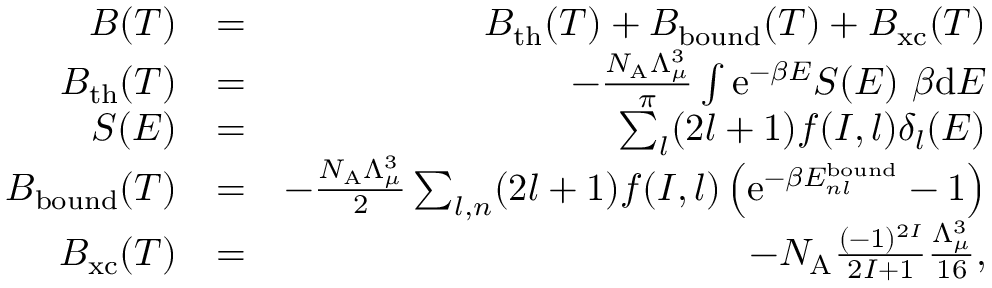<formula> <loc_0><loc_0><loc_500><loc_500>\begin{array} { r l r } { B ( T ) } & { = } & { B _ { t h } ( T ) + B _ { b o u n d } ( T ) + B _ { x c } ( T ) } \\ { B _ { t h } ( T ) } & { = } & { - \frac { N _ { A } \Lambda _ { \mu } ^ { 3 } } { \pi } \int e ^ { - \beta E } S ( E ) \beta d E } \\ { S ( E ) } & { = } & { \sum _ { l } ( 2 l + 1 ) f ( I , l ) \delta _ { l } ( E ) } \\ { B _ { b o u n d } ( T ) } & { = } & { - \frac { N _ { A } \Lambda _ { \mu } ^ { 3 } } { 2 } \sum _ { l , n } ( 2 l + 1 ) f ( I , l ) \left ( e ^ { - \beta E _ { n l } ^ { b o u n d } } - 1 \right ) } \\ { B _ { x c } ( T ) } & { = } & { - N _ { A } \frac { ( - 1 ) ^ { 2 I } } { 2 I + 1 } \frac { \Lambda _ { \mu } ^ { 3 } } { 1 6 } , } \end{array}</formula> 